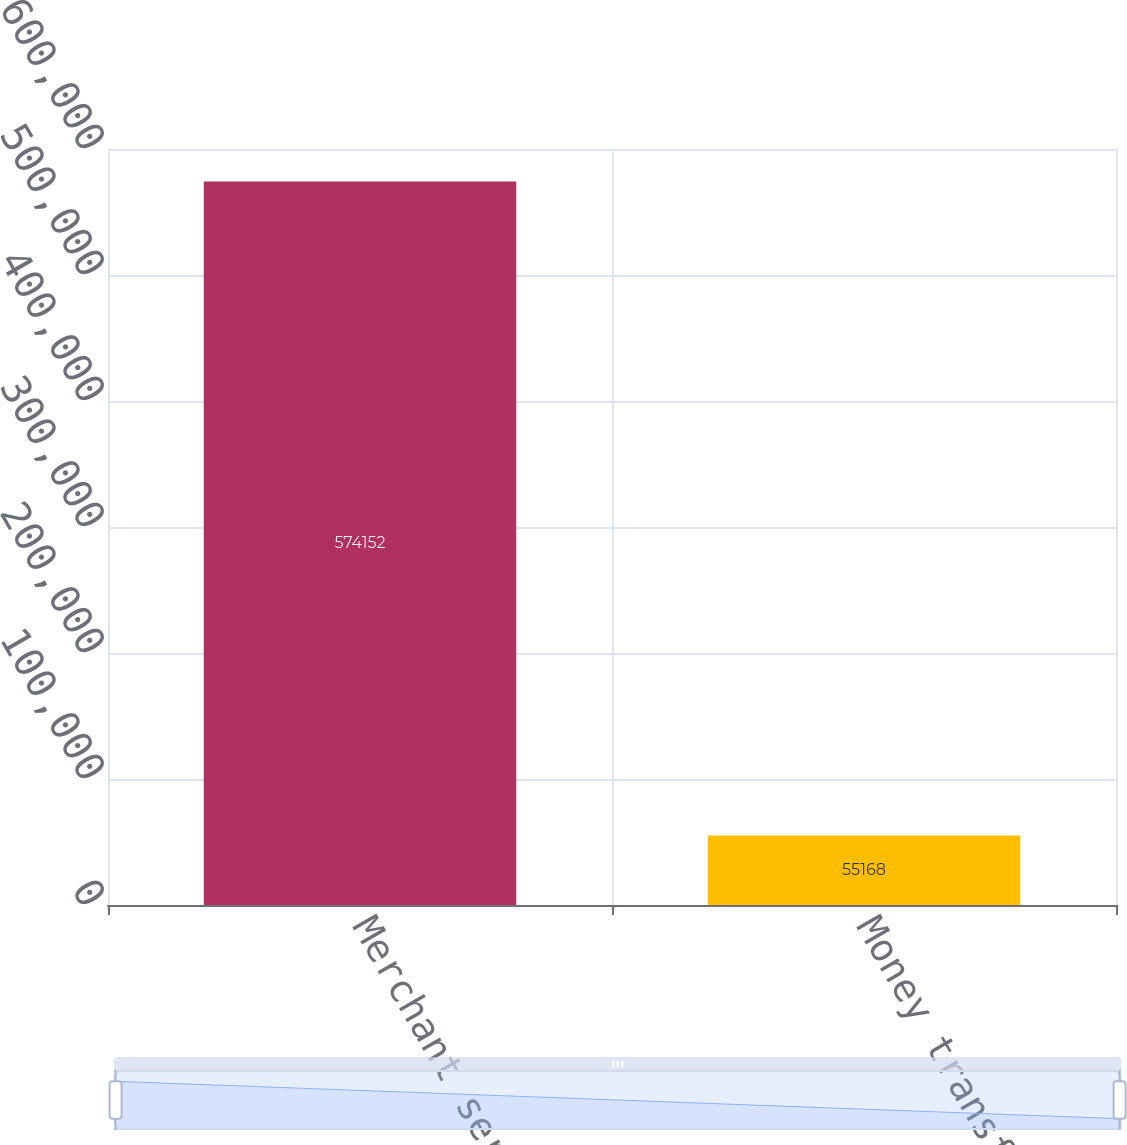Convert chart. <chart><loc_0><loc_0><loc_500><loc_500><bar_chart><fcel>Merchant services<fcel>Money transfer<nl><fcel>574152<fcel>55168<nl></chart> 